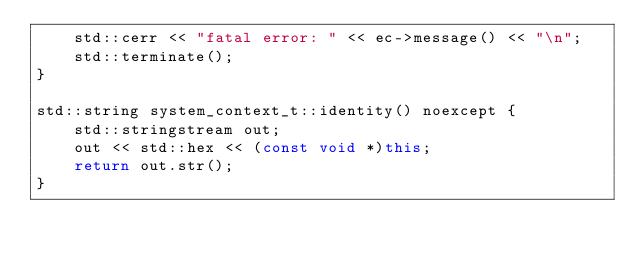Convert code to text. <code><loc_0><loc_0><loc_500><loc_500><_C++_>    std::cerr << "fatal error: " << ec->message() << "\n";
    std::terminate();
}

std::string system_context_t::identity() noexcept {
    std::stringstream out;
    out << std::hex << (const void *)this;
    return out.str();
}
</code> 